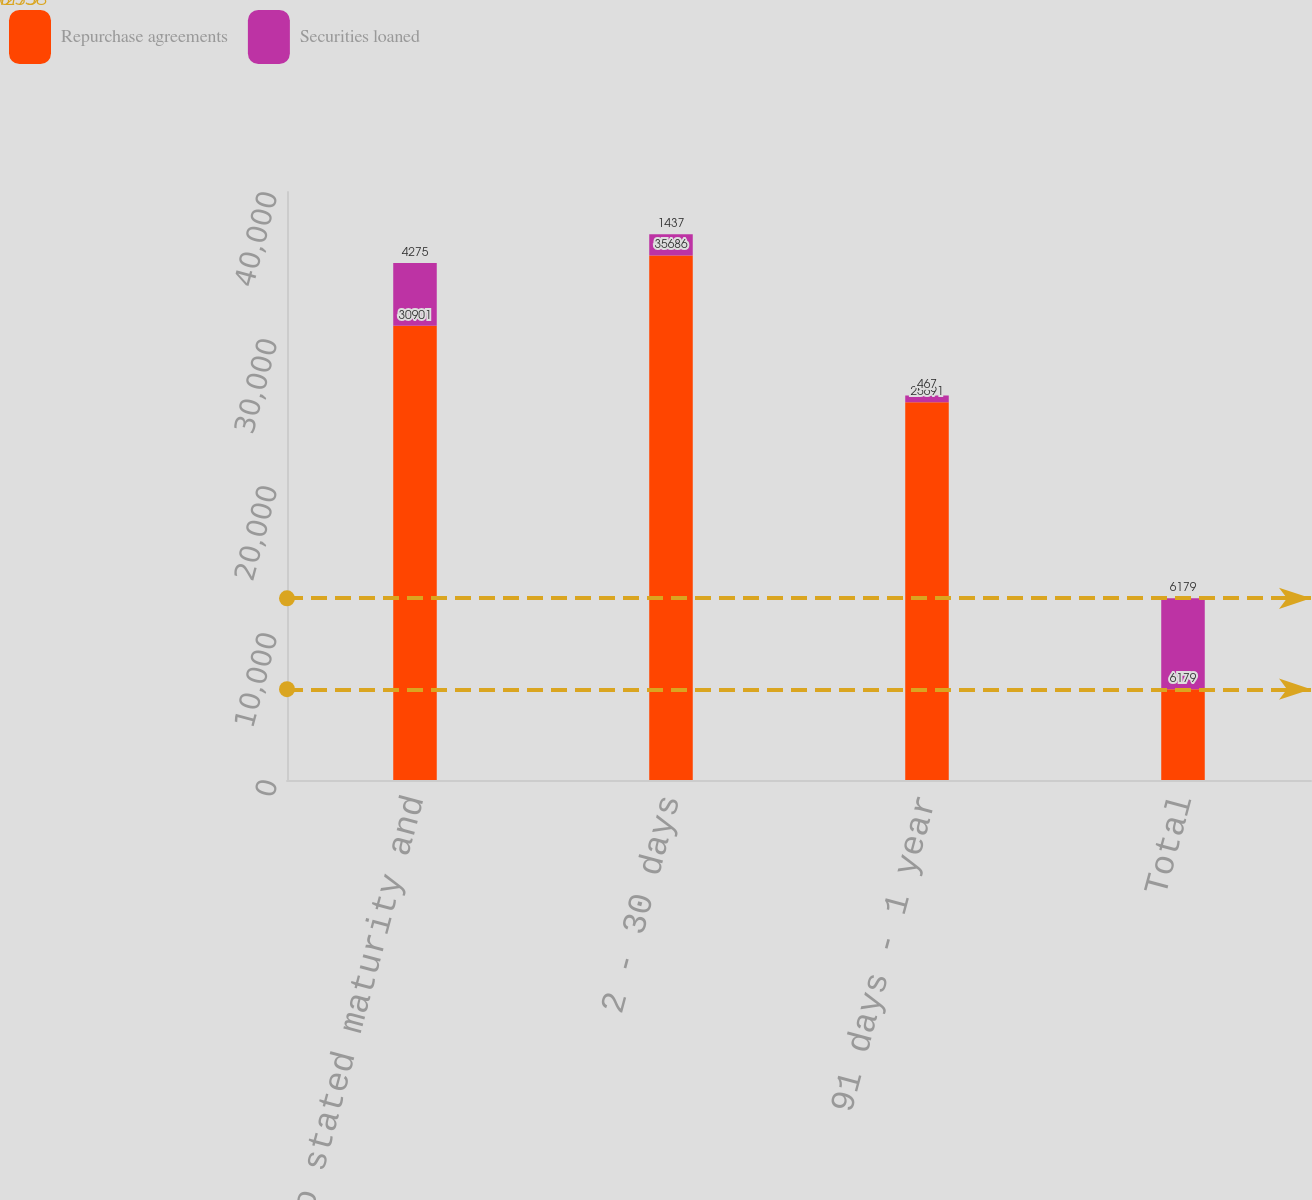<chart> <loc_0><loc_0><loc_500><loc_500><stacked_bar_chart><ecel><fcel>No stated maturity and<fcel>2 - 30 days<fcel>91 days - 1 year<fcel>Total<nl><fcel>Repurchase agreements<fcel>30901<fcel>35686<fcel>25691<fcel>6179<nl><fcel>Securities loaned<fcel>4275<fcel>1437<fcel>467<fcel>6179<nl></chart> 